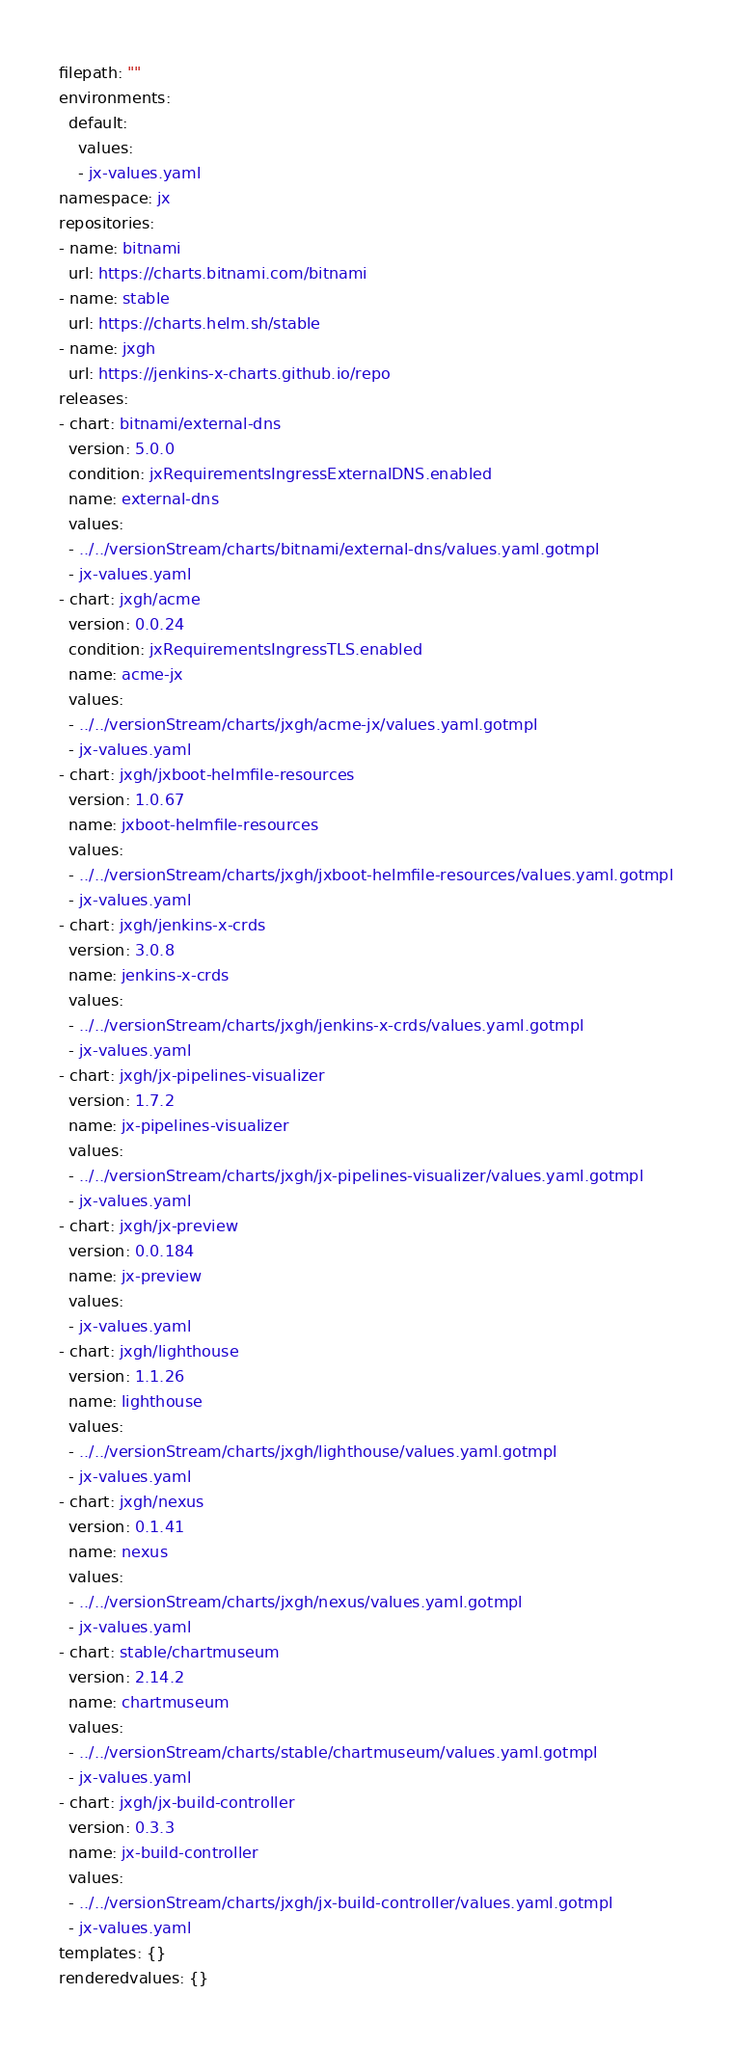Convert code to text. <code><loc_0><loc_0><loc_500><loc_500><_YAML_>filepath: ""
environments:
  default:
    values:
    - jx-values.yaml
namespace: jx
repositories:
- name: bitnami
  url: https://charts.bitnami.com/bitnami
- name: stable
  url: https://charts.helm.sh/stable
- name: jxgh
  url: https://jenkins-x-charts.github.io/repo
releases:
- chart: bitnami/external-dns
  version: 5.0.0
  condition: jxRequirementsIngressExternalDNS.enabled
  name: external-dns
  values:
  - ../../versionStream/charts/bitnami/external-dns/values.yaml.gotmpl
  - jx-values.yaml
- chart: jxgh/acme
  version: 0.0.24
  condition: jxRequirementsIngressTLS.enabled
  name: acme-jx
  values:
  - ../../versionStream/charts/jxgh/acme-jx/values.yaml.gotmpl
  - jx-values.yaml
- chart: jxgh/jxboot-helmfile-resources
  version: 1.0.67
  name: jxboot-helmfile-resources
  values:
  - ../../versionStream/charts/jxgh/jxboot-helmfile-resources/values.yaml.gotmpl
  - jx-values.yaml
- chart: jxgh/jenkins-x-crds
  version: 3.0.8
  name: jenkins-x-crds
  values:
  - ../../versionStream/charts/jxgh/jenkins-x-crds/values.yaml.gotmpl
  - jx-values.yaml
- chart: jxgh/jx-pipelines-visualizer
  version: 1.7.2
  name: jx-pipelines-visualizer
  values:
  - ../../versionStream/charts/jxgh/jx-pipelines-visualizer/values.yaml.gotmpl
  - jx-values.yaml
- chart: jxgh/jx-preview
  version: 0.0.184
  name: jx-preview
  values:
  - jx-values.yaml
- chart: jxgh/lighthouse
  version: 1.1.26
  name: lighthouse
  values:
  - ../../versionStream/charts/jxgh/lighthouse/values.yaml.gotmpl
  - jx-values.yaml
- chart: jxgh/nexus
  version: 0.1.41
  name: nexus
  values:
  - ../../versionStream/charts/jxgh/nexus/values.yaml.gotmpl
  - jx-values.yaml
- chart: stable/chartmuseum
  version: 2.14.2
  name: chartmuseum
  values:
  - ../../versionStream/charts/stable/chartmuseum/values.yaml.gotmpl
  - jx-values.yaml
- chart: jxgh/jx-build-controller
  version: 0.3.3
  name: jx-build-controller
  values:
  - ../../versionStream/charts/jxgh/jx-build-controller/values.yaml.gotmpl
  - jx-values.yaml
templates: {}
renderedvalues: {}
</code> 